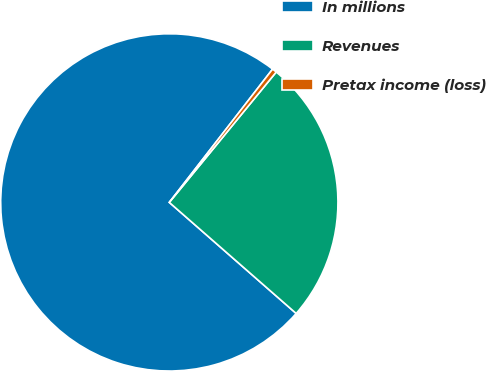Convert chart to OTSL. <chart><loc_0><loc_0><loc_500><loc_500><pie_chart><fcel>In millions<fcel>Revenues<fcel>Pretax income (loss)<nl><fcel>74.04%<fcel>25.51%<fcel>0.44%<nl></chart> 